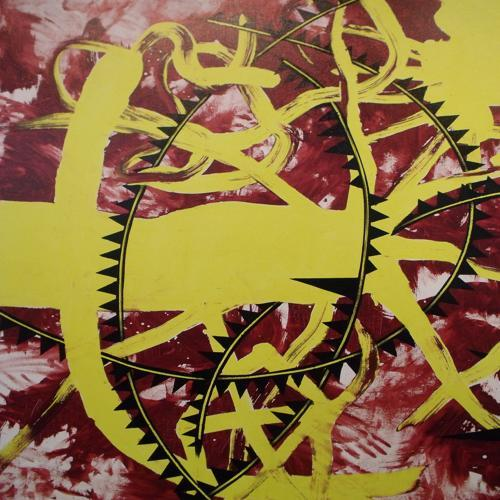What artistic techniques can be observed in this image? The image features expressive brushwork and a bold use of color contrasts. Abstract shapes are formed by strong lines, which create a sense of movement and rhythm throughout the composition. Does this image invoke any particular emotions or ideas? Certainly, the vivid colors and assertive lines may evoke feelings of dynamism and intensity, perhaps reflecting themes of chaos or complexity. 